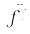Convert formula to latex. <formula><loc_0><loc_0><loc_500><loc_500>\vec { f ^ { j } }</formula> 